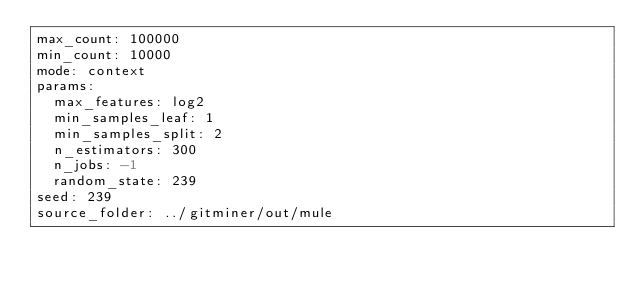<code> <loc_0><loc_0><loc_500><loc_500><_YAML_>max_count: 100000
min_count: 10000
mode: context
params:
  max_features: log2
  min_samples_leaf: 1
  min_samples_split: 2
  n_estimators: 300
  n_jobs: -1
  random_state: 239
seed: 239
source_folder: ../gitminer/out/mule
</code> 